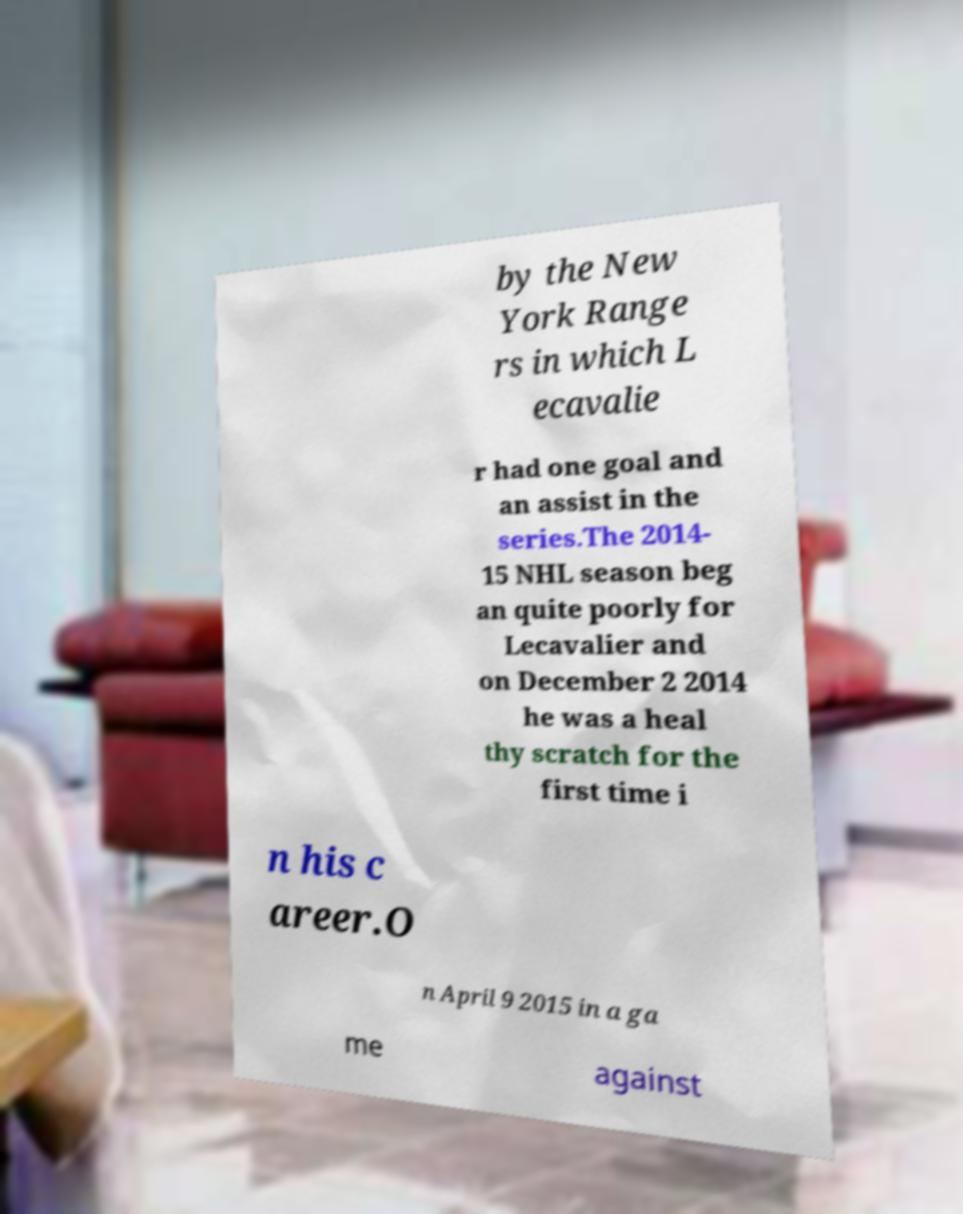Please read and relay the text visible in this image. What does it say? by the New York Range rs in which L ecavalie r had one goal and an assist in the series.The 2014- 15 NHL season beg an quite poorly for Lecavalier and on December 2 2014 he was a heal thy scratch for the first time i n his c areer.O n April 9 2015 in a ga me against 